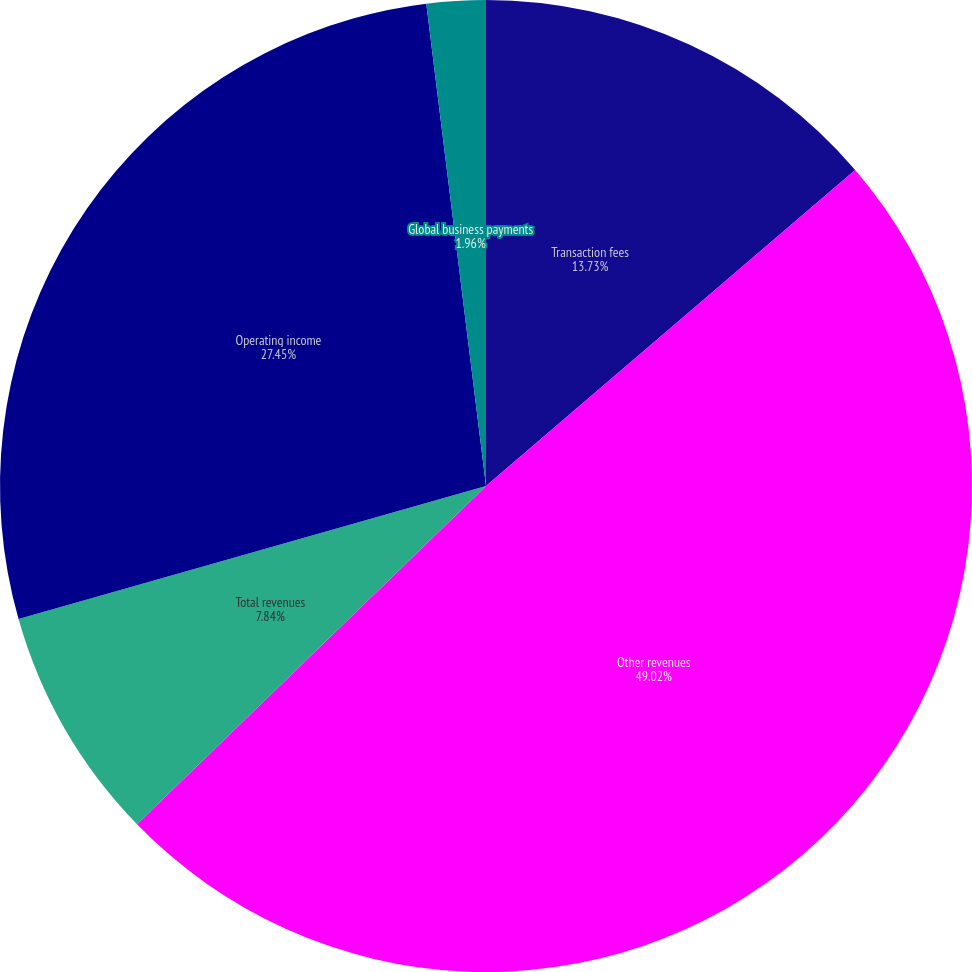Convert chart to OTSL. <chart><loc_0><loc_0><loc_500><loc_500><pie_chart><fcel>Transaction fees<fcel>Other revenues<fcel>Total revenues<fcel>Operating income<fcel>Global business payments<nl><fcel>13.73%<fcel>49.02%<fcel>7.84%<fcel>27.45%<fcel>1.96%<nl></chart> 